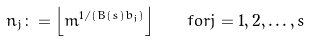<formula> <loc_0><loc_0><loc_500><loc_500>n _ { j } \colon = \left \lfloor m ^ { 1 / ( B ( s ) b _ { j } ) } \right \rfloor \quad f o r j = 1 , 2 , \dots , s</formula> 